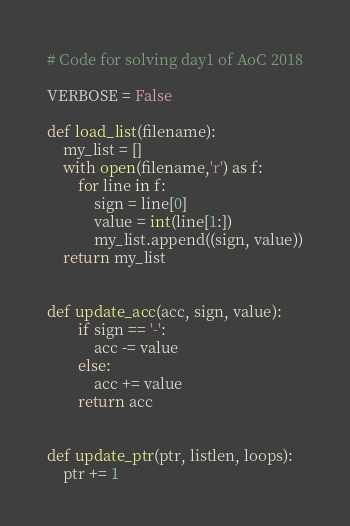<code> <loc_0><loc_0><loc_500><loc_500><_Python_># Code for solving day1 of AoC 2018

VERBOSE = False

def load_list(filename):
    my_list = []
    with open(filename,'r') as f:
        for line in f:
            sign = line[0]
            value = int(line[1:])
            my_list.append((sign, value))
    return my_list


def update_acc(acc, sign, value):
        if sign == '-':
            acc -= value
        else:
            acc += value
        return acc


def update_ptr(ptr, listlen, loops):
    ptr += 1</code> 